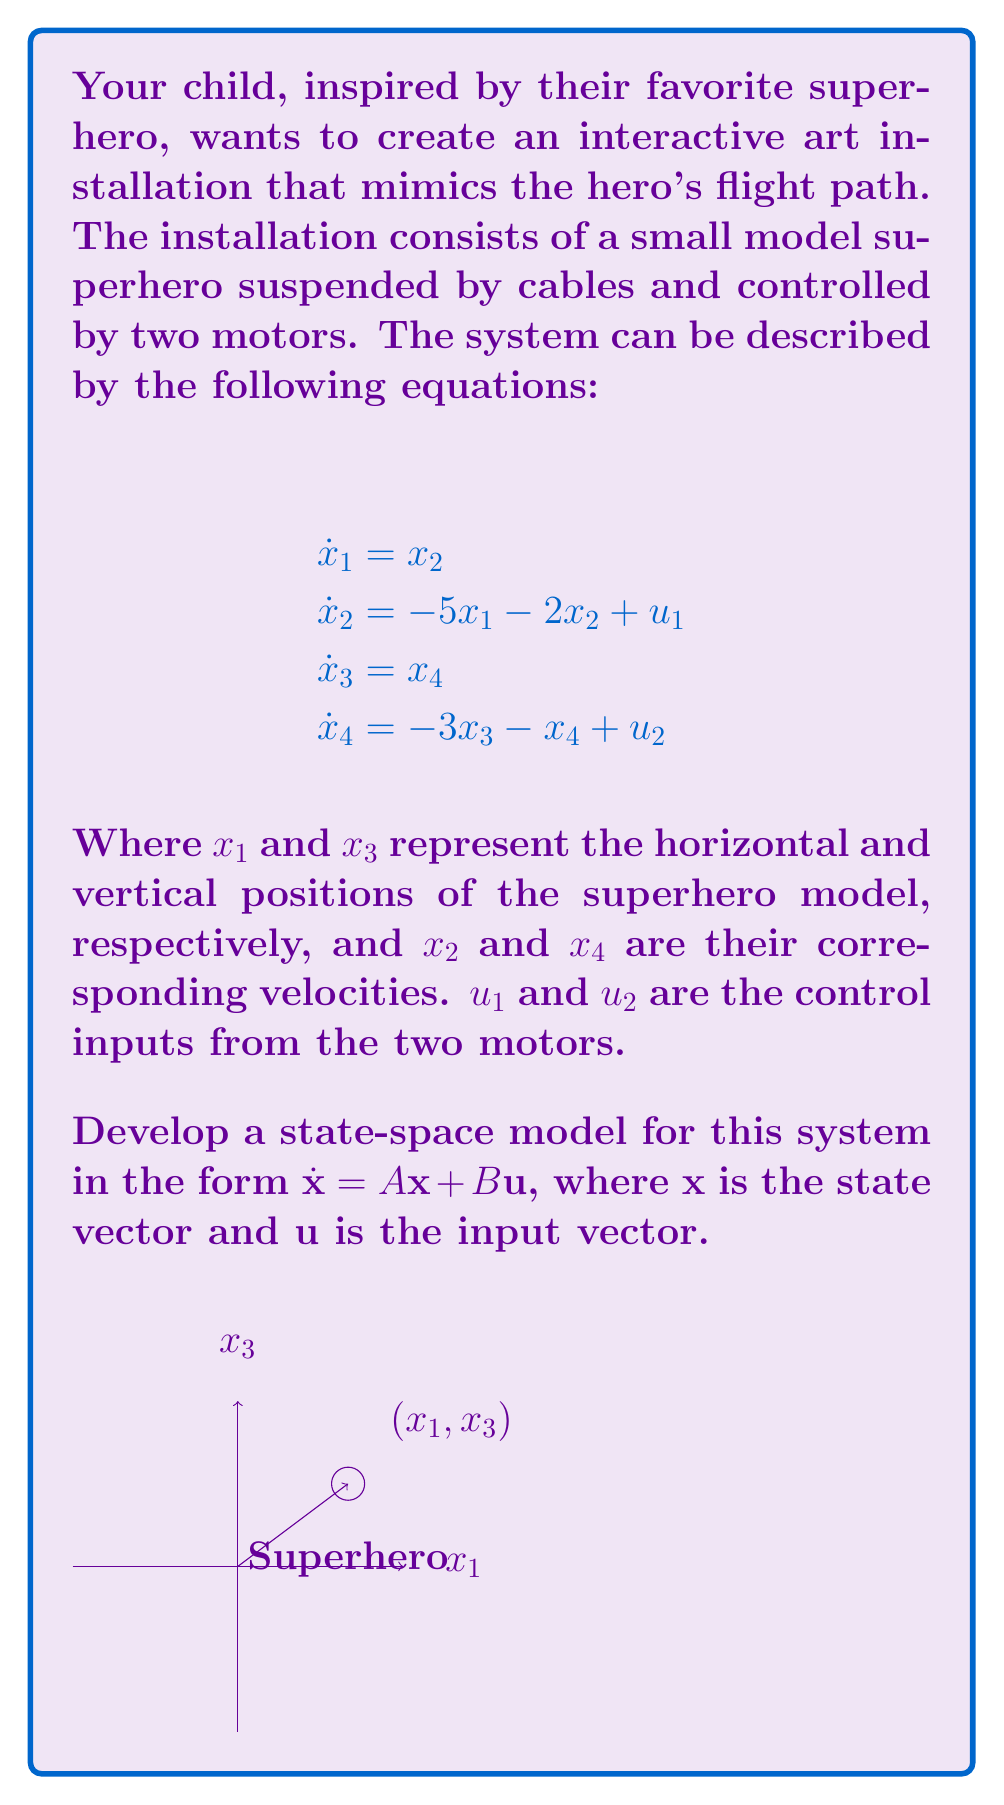Show me your answer to this math problem. To develop the state-space model, we need to follow these steps:

1. Identify the state variables:
   $x_1$: horizontal position
   $x_2$: horizontal velocity
   $x_3$: vertical position
   $x_4$: vertical velocity

2. Define the state vector $\mathbf{x}$:
   $$\mathbf{x} = \begin{bmatrix} x_1 \\ x_2 \\ x_3 \\ x_4 \end{bmatrix}$$

3. Define the input vector $\mathbf{u}$:
   $$\mathbf{u} = \begin{bmatrix} u_1 \\ u_2 \end{bmatrix}$$

4. Construct the state matrix $A$ based on the given equations:
   $$A = \begin{bmatrix}
   0 & 1 & 0 & 0 \\
   -5 & -2 & 0 & 0 \\
   0 & 0 & 0 & 1 \\
   0 & 0 & -3 & -1
   \end{bmatrix}$$

5. Construct the input matrix $B$ based on the given equations:
   $$B = \begin{bmatrix}
   0 & 0 \\
   1 & 0 \\
   0 & 0 \\
   0 & 1
   \end{bmatrix}$$

6. Write the state-space model in the form $\dot{\mathbf{x}} = A\mathbf{x} + B\mathbf{u}$:
   $$\begin{bmatrix} \dot{x}_1 \\ \dot{x}_2 \\ \dot{x}_3 \\ \dot{x}_4 \end{bmatrix} = 
   \begin{bmatrix}
   0 & 1 & 0 & 0 \\
   -5 & -2 & 0 & 0 \\
   0 & 0 & 0 & 1 \\
   0 & 0 & -3 & -1
   \end{bmatrix}
   \begin{bmatrix} x_1 \\ x_2 \\ x_3 \\ x_4 \end{bmatrix} +
   \begin{bmatrix}
   0 & 0 \\
   1 & 0 \\
   0 & 0 \\
   0 & 1
   \end{bmatrix}
   \begin{bmatrix} u_1 \\ u_2 \end{bmatrix}$$

This state-space model represents the dynamic behavior of the interactive art installation's motion control system, allowing for the control of the superhero model's position and velocity in both horizontal and vertical directions.
Answer: $$\dot{\mathbf{x}} = \begin{bmatrix}
0 & 1 & 0 & 0 \\
-5 & -2 & 0 & 0 \\
0 & 0 & 0 & 1 \\
0 & 0 & -3 & -1
\end{bmatrix}\mathbf{x} + 
\begin{bmatrix}
0 & 0 \\
1 & 0 \\
0 & 0 \\
0 & 1
\end{bmatrix}\mathbf{u}$$ 